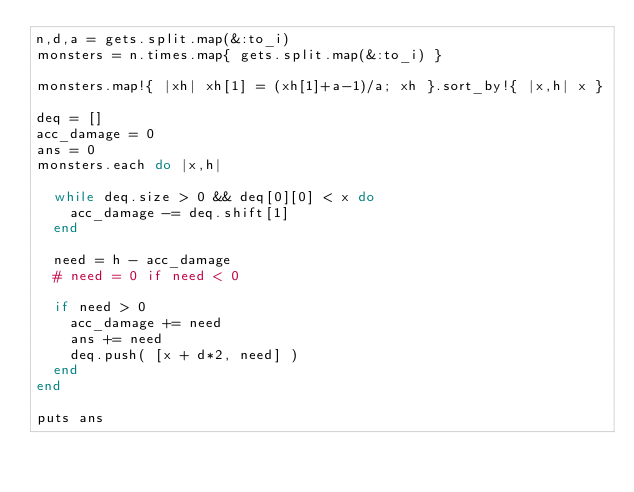<code> <loc_0><loc_0><loc_500><loc_500><_Ruby_>n,d,a = gets.split.map(&:to_i)
monsters = n.times.map{ gets.split.map(&:to_i) } 

monsters.map!{ |xh| xh[1] = (xh[1]+a-1)/a; xh }.sort_by!{ |x,h| x }

deq = []
acc_damage = 0
ans = 0
monsters.each do |x,h|
  
  while deq.size > 0 && deq[0][0] < x do
    acc_damage -= deq.shift[1]
  end
  
  need = h - acc_damage
  # need = 0 if need < 0
  
  if need > 0
    acc_damage += need
    ans += need
    deq.push( [x + d*2, need] )
  end
end

puts ans</code> 